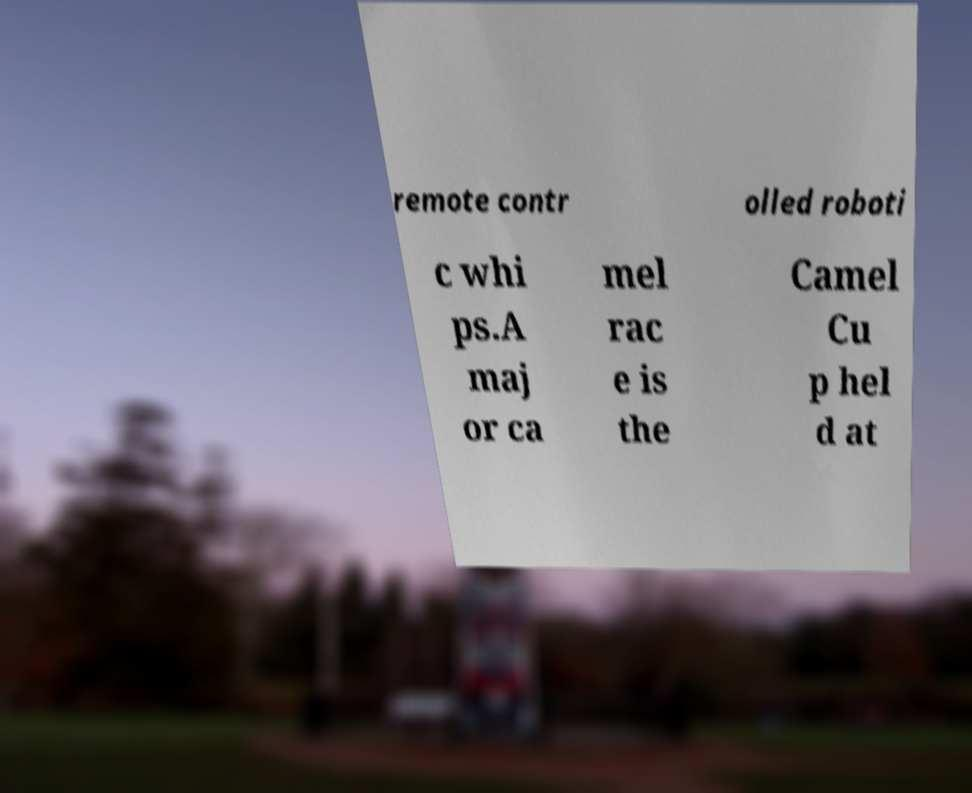Could you extract and type out the text from this image? remote contr olled roboti c whi ps.A maj or ca mel rac e is the Camel Cu p hel d at 